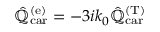Convert formula to latex. <formula><loc_0><loc_0><loc_500><loc_500>\hat { \mathbb { Q } } _ { c a r } ^ { ( e ) } = - 3 i k _ { 0 } \hat { \mathbb { Q } } _ { c a r } ^ { ( T ) }</formula> 